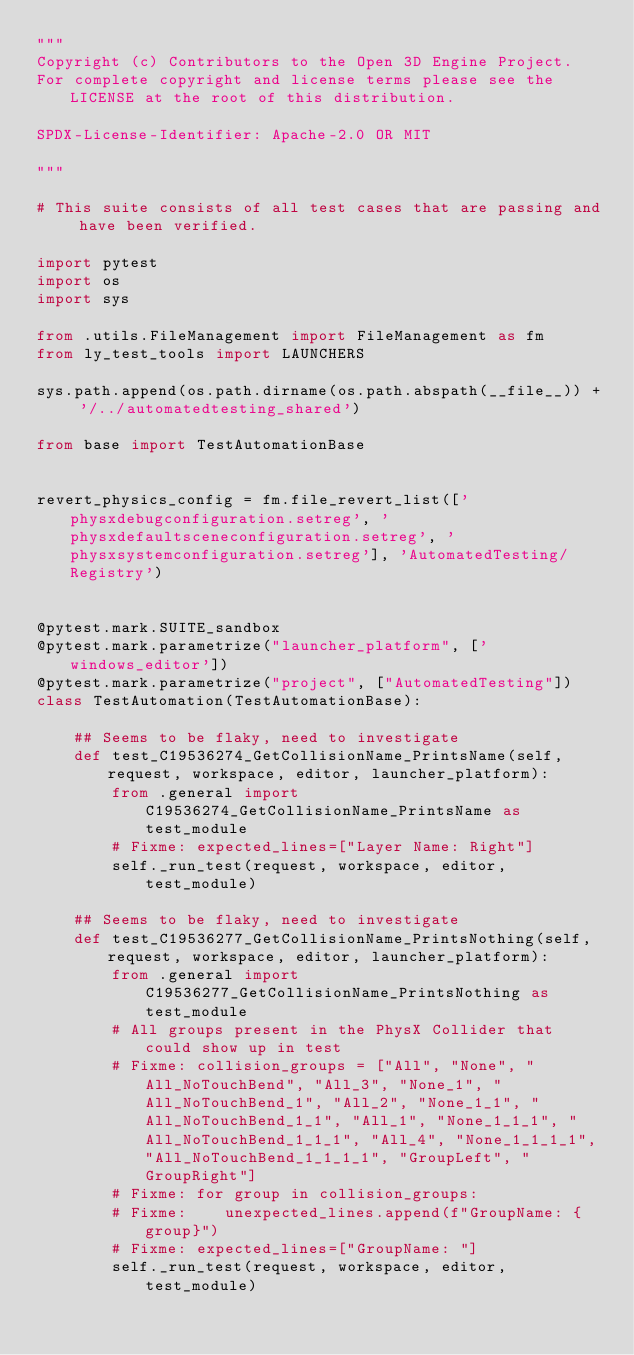Convert code to text. <code><loc_0><loc_0><loc_500><loc_500><_Python_>"""
Copyright (c) Contributors to the Open 3D Engine Project.
For complete copyright and license terms please see the LICENSE at the root of this distribution.

SPDX-License-Identifier: Apache-2.0 OR MIT

"""

# This suite consists of all test cases that are passing and have been verified.

import pytest
import os
import sys

from .utils.FileManagement import FileManagement as fm
from ly_test_tools import LAUNCHERS

sys.path.append(os.path.dirname(os.path.abspath(__file__)) + '/../automatedtesting_shared')

from base import TestAutomationBase


revert_physics_config = fm.file_revert_list(['physxdebugconfiguration.setreg', 'physxdefaultsceneconfiguration.setreg', 'physxsystemconfiguration.setreg'], 'AutomatedTesting/Registry')


@pytest.mark.SUITE_sandbox
@pytest.mark.parametrize("launcher_platform", ['windows_editor'])
@pytest.mark.parametrize("project", ["AutomatedTesting"])
class TestAutomation(TestAutomationBase):

    ## Seems to be flaky, need to investigate
    def test_C19536274_GetCollisionName_PrintsName(self, request, workspace, editor, launcher_platform):
        from .general import C19536274_GetCollisionName_PrintsName as test_module
        # Fixme: expected_lines=["Layer Name: Right"]
        self._run_test(request, workspace, editor, test_module)

    ## Seems to be flaky, need to investigate
    def test_C19536277_GetCollisionName_PrintsNothing(self, request, workspace, editor, launcher_platform):
        from .general import C19536277_GetCollisionName_PrintsNothing as test_module
        # All groups present in the PhysX Collider that could show up in test
        # Fixme: collision_groups = ["All", "None", "All_NoTouchBend", "All_3", "None_1", "All_NoTouchBend_1", "All_2", "None_1_1", "All_NoTouchBend_1_1", "All_1", "None_1_1_1", "All_NoTouchBend_1_1_1", "All_4", "None_1_1_1_1", "All_NoTouchBend_1_1_1_1", "GroupLeft", "GroupRight"]
        # Fixme: for group in collision_groups:
        # Fixme:    unexpected_lines.append(f"GroupName: {group}")
        # Fixme: expected_lines=["GroupName: "]
        self._run_test(request, workspace, editor, test_module)
</code> 